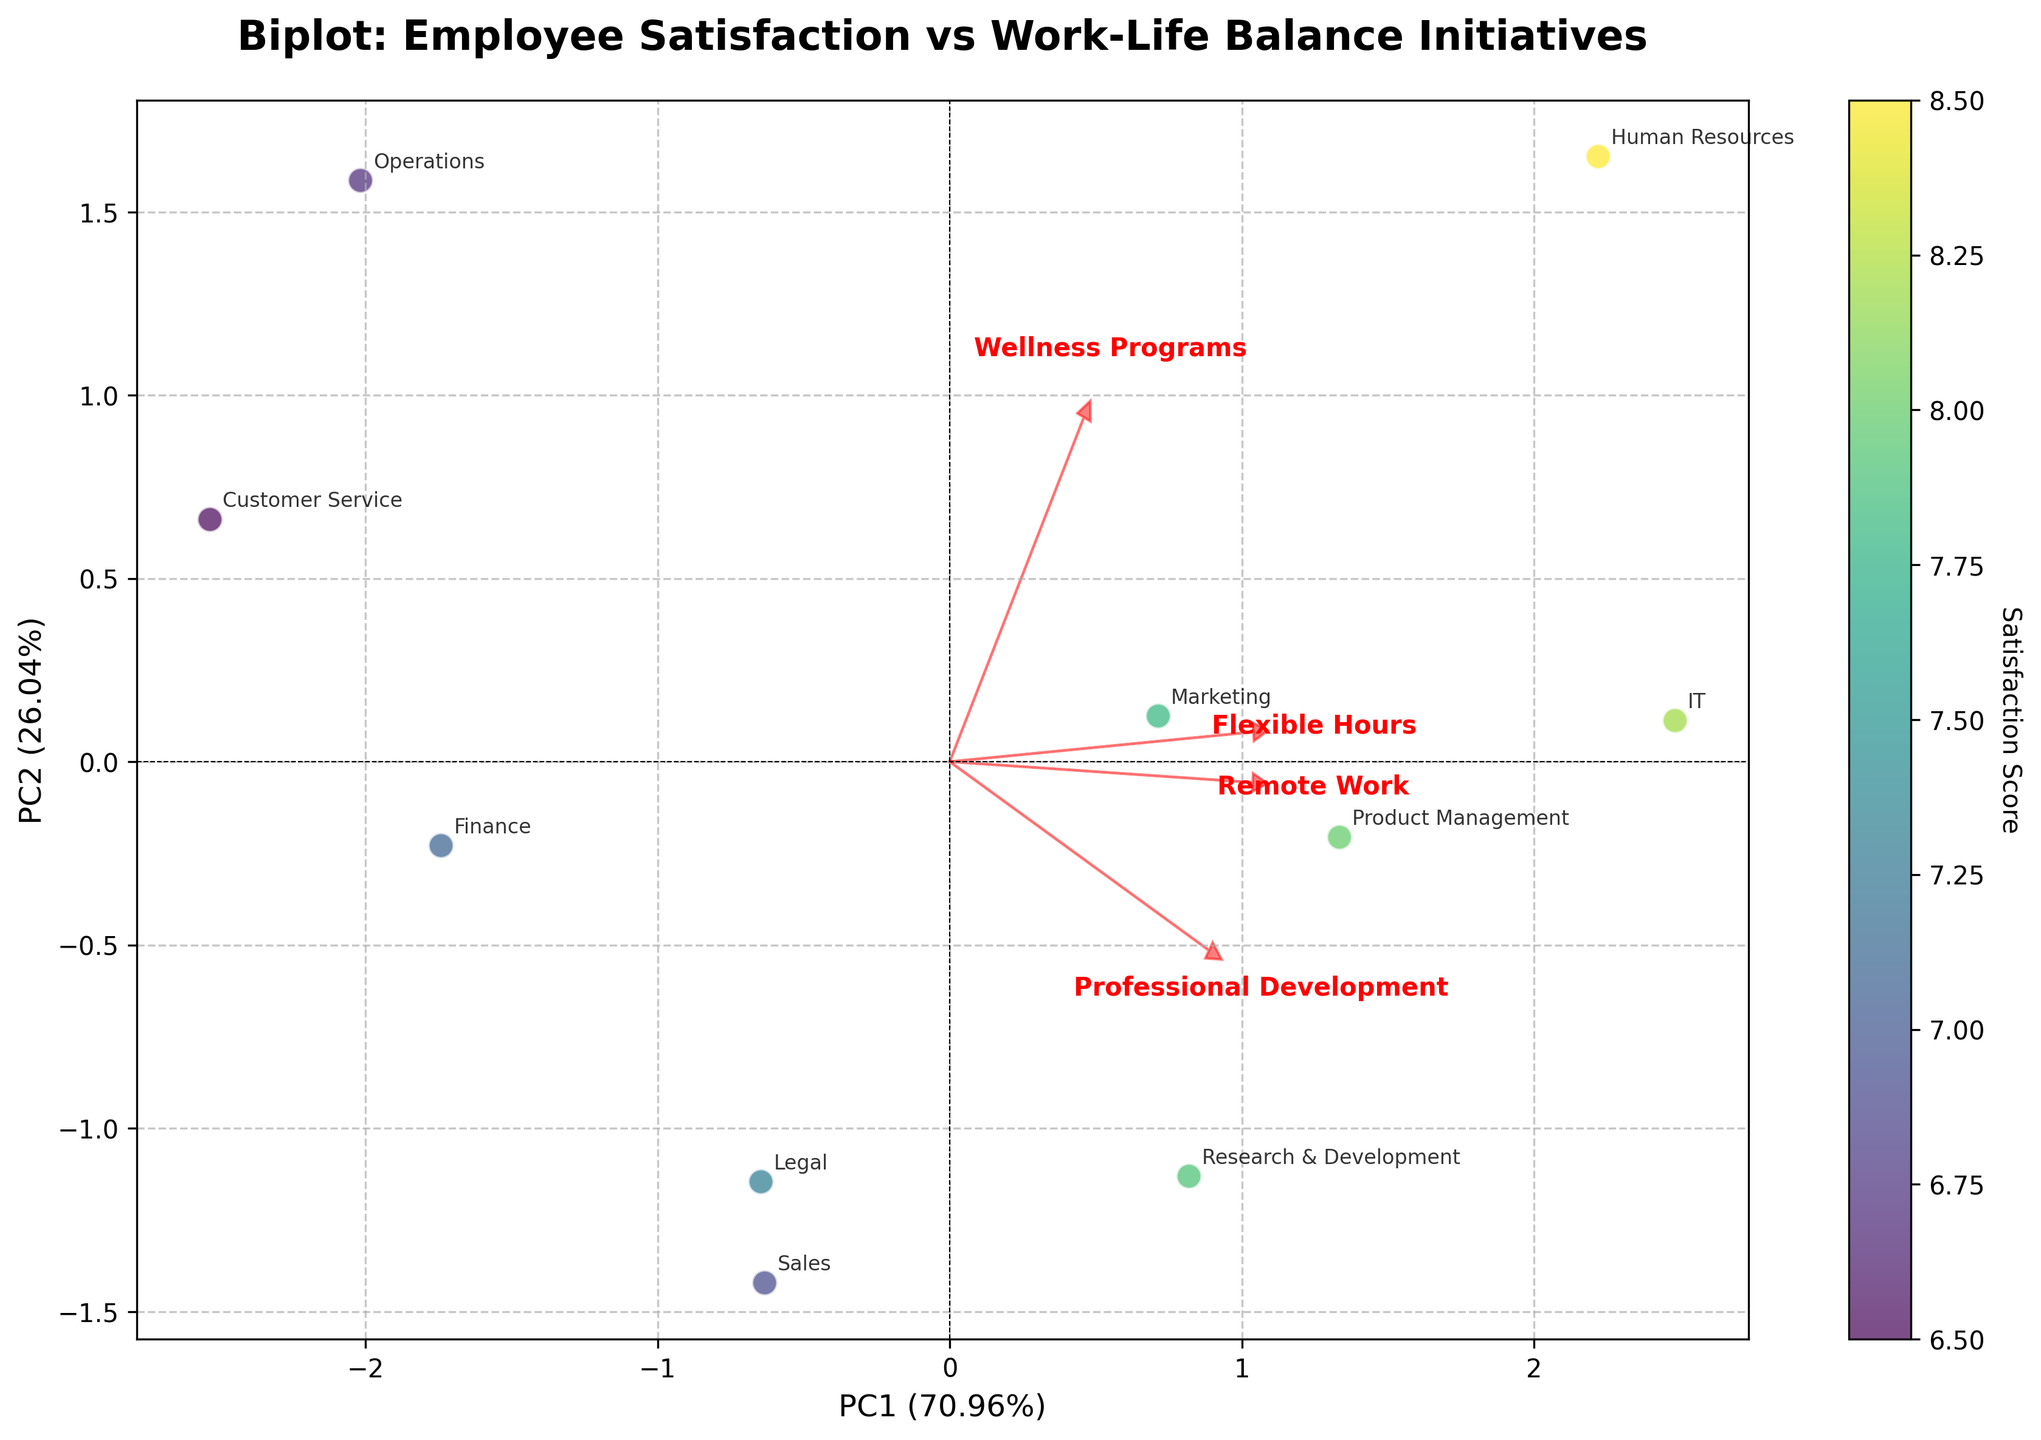What's the title of the figure? The title of the figure is prominently displayed at the top and provides an overview of the chart. In this case, we can read it as: "Biplot: Employee Satisfaction vs Work-Life Balance Initiatives"
Answer: Biplot: Employee Satisfaction vs Work-Life Balance Initiatives Which department has the highest satisfaction score? From the plot, we can see that the data points are color-coded by the satisfaction score. By observing the colorbar and the color-coded points, we identify the department whose point is in the range of highest satisfaction score. Here, Human Resources has the highest satisfaction score.
Answer: Human Resources Which feature vector appears longest? By seeing how far each red feature arrow extends from the origin, we can determine which vector is longest. From the plot, it appears that the "Professional Development" feature vector is the longest among all.
Answer: Professional Development Which departments are closest to each other in terms of their PCA scores? By observing the data points' position on the plot, the departments whose points are closest to each other spatially in the biplot are close in terms of PCA scores. For example, the departments Marketing and Product Management are very close together, suggesting similarity in their PCA scores.
Answer: Marketing and Product Management Which work-life balance initiatives most influence the first principal component (PC1)? The influence of features on PC1 is indicated by their loading values on the x-axis. The feature arrow pointing most prominently along the x-axis signifies the greatest influence on PC1. Here, both "Flexible Hours" and "Professional Development" have high values.
Answer: Flexible Hours and Professional Development Which departments fall along the right-hand side of PC1? Data points located towards the right along the x-axis (PC1) highlight departments with positive scores on PC1. Observing the plot, IT and Human Resources are among the departments on the right-hand side.
Answer: IT and Human Resources Are there any departments that score similarly across multiple work-life balance initiatives? Departments whose points fall along similar directional lines extending from the origin towards the feature vectors suggest similar scoring across multiple work-life balance initiatives. Human Resources scoring highly on different initiatives such as Flexible Hours, Remote Work, and Wellness Programs suggests similarity in scoring.
Answer: Human Resources Which work-life balance initiatives correlate most closely with each other? By observing how closely the feature arrows align with each other, we can infer the correlation. "Flexible Hours" and "Professional Development," which align closely, have strong correlations.
Answer: Flexible Hours and Professional Development How does the "Wellness Programs" initiative influence the employee satisfaction score? Observing the plot, we see that the "Wellness Programs" feature vector indicates substantial contribution to the second principal component (PC2). Departments that have strong involvement in Wellness Programs tend to have higher satisfaction scores (e.g., Human Resources).
Answer: Positive influence 